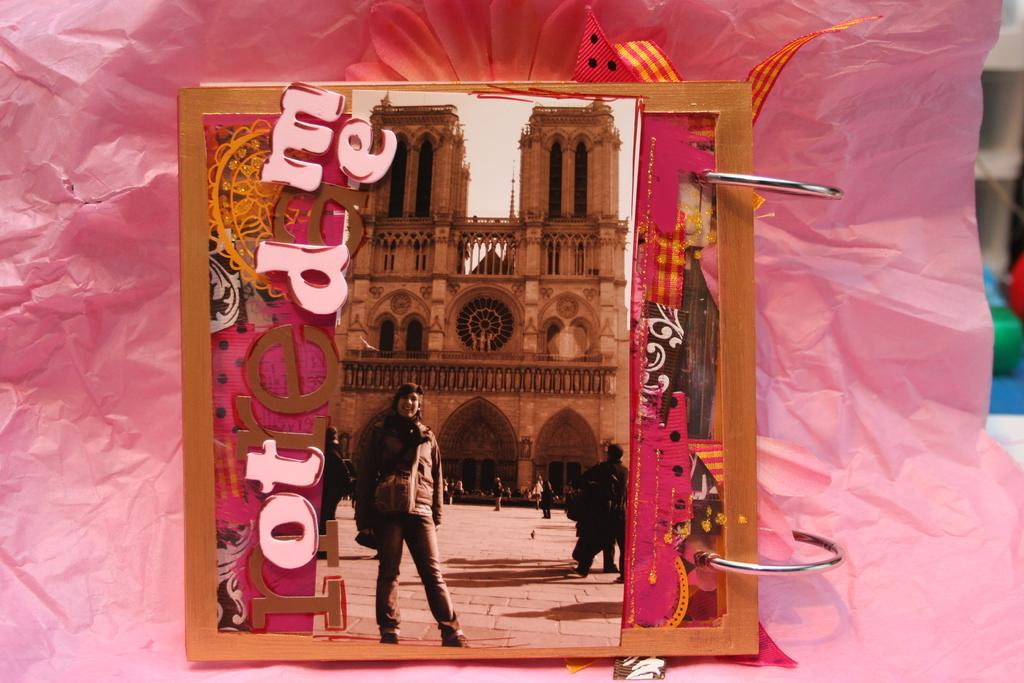What object is present in the image that typically holds a photograph? There is a photo frame in the image. What is the photo frame attached to? The photo frame is attached to a paper. Where is the photo frame located in the image? The photo frame is located at the center of the image. What type of vegetable is growing in the photo frame? There is no vegetable growing in the photo frame; it is a frame for holding a photograph. 